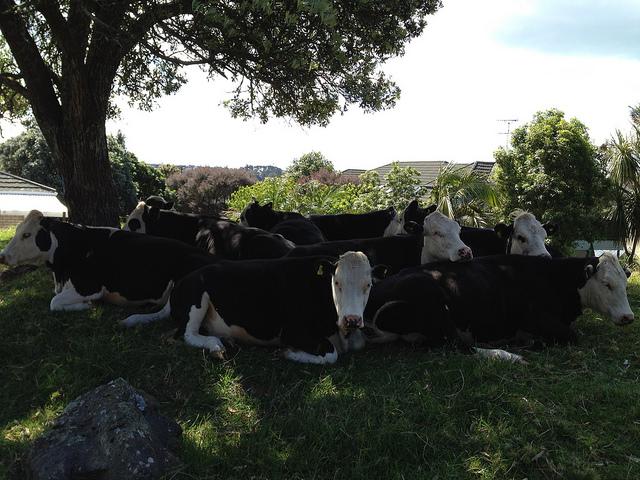Why are the cows under the tree?
Be succinct. Shade. Do the cows look content?
Quick response, please. Yes. Are the cows sleeping?
Write a very short answer. Yes. 